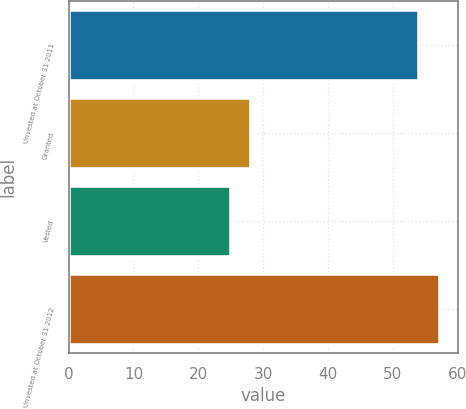Convert chart. <chart><loc_0><loc_0><loc_500><loc_500><bar_chart><fcel>Unvested at October 31 2011<fcel>Granted<fcel>Vested<fcel>Unvested at October 31 2012<nl><fcel>54<fcel>28.2<fcel>25<fcel>57.2<nl></chart> 